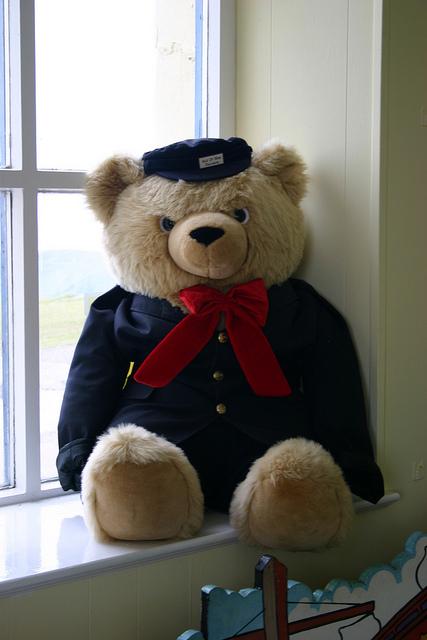What is hanging off the bear's ear?
Be succinct. Nothing. Is this bear wearing clothes?
Short answer required. Yes. Where is light coming from?
Write a very short answer. Window. What is the bear sitting on?
Quick response, please. Window sill. 